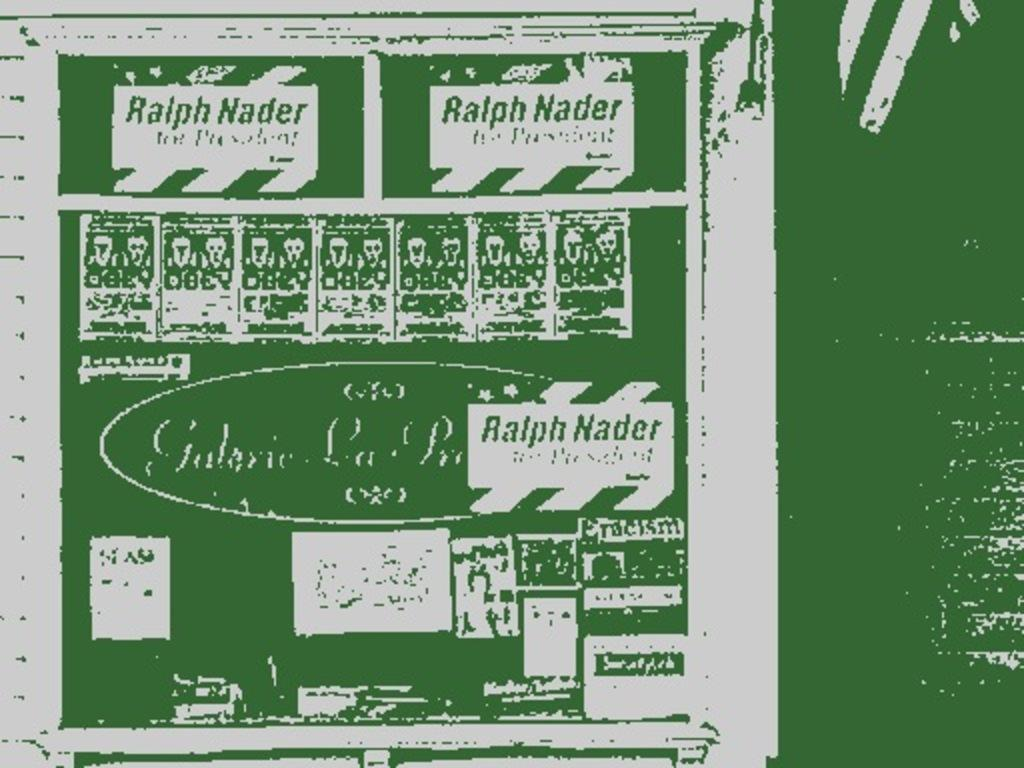<image>
Offer a succinct explanation of the picture presented. A green and white poster about Ralph Nader. 